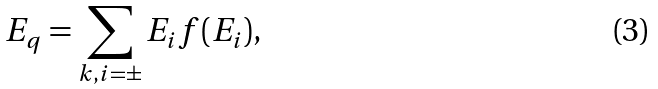<formula> <loc_0><loc_0><loc_500><loc_500>E _ { q } = \sum _ { k , i = \pm } E _ { i } f ( E _ { i } ) ,</formula> 